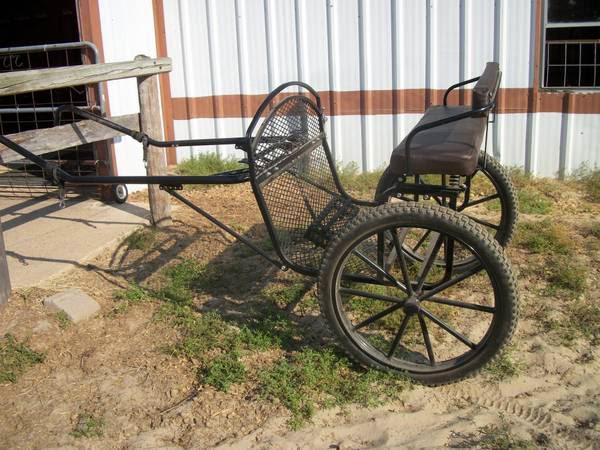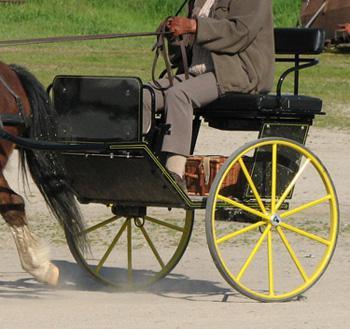The first image is the image on the left, the second image is the image on the right. Examine the images to the left and right. Is the description "Left image features a four-wheeled black cart." accurate? Answer yes or no. No. The first image is the image on the left, the second image is the image on the right. Examine the images to the left and right. Is the description "The carriage on the right most image has yellow wheels." accurate? Answer yes or no. Yes. 